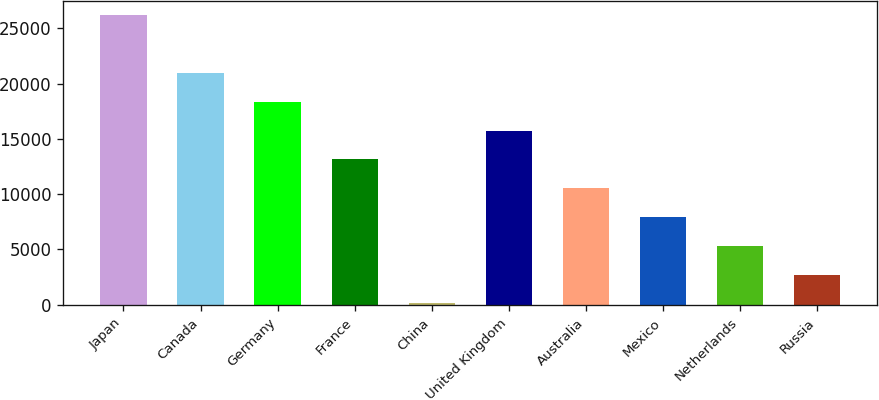<chart> <loc_0><loc_0><loc_500><loc_500><bar_chart><fcel>Japan<fcel>Canada<fcel>Germany<fcel>France<fcel>China<fcel>United Kingdom<fcel>Australia<fcel>Mexico<fcel>Netherlands<fcel>Russia<nl><fcel>26171<fcel>20963.2<fcel>18359.3<fcel>13151.5<fcel>132<fcel>15755.4<fcel>10547.6<fcel>7943.7<fcel>5339.8<fcel>2735.9<nl></chart> 